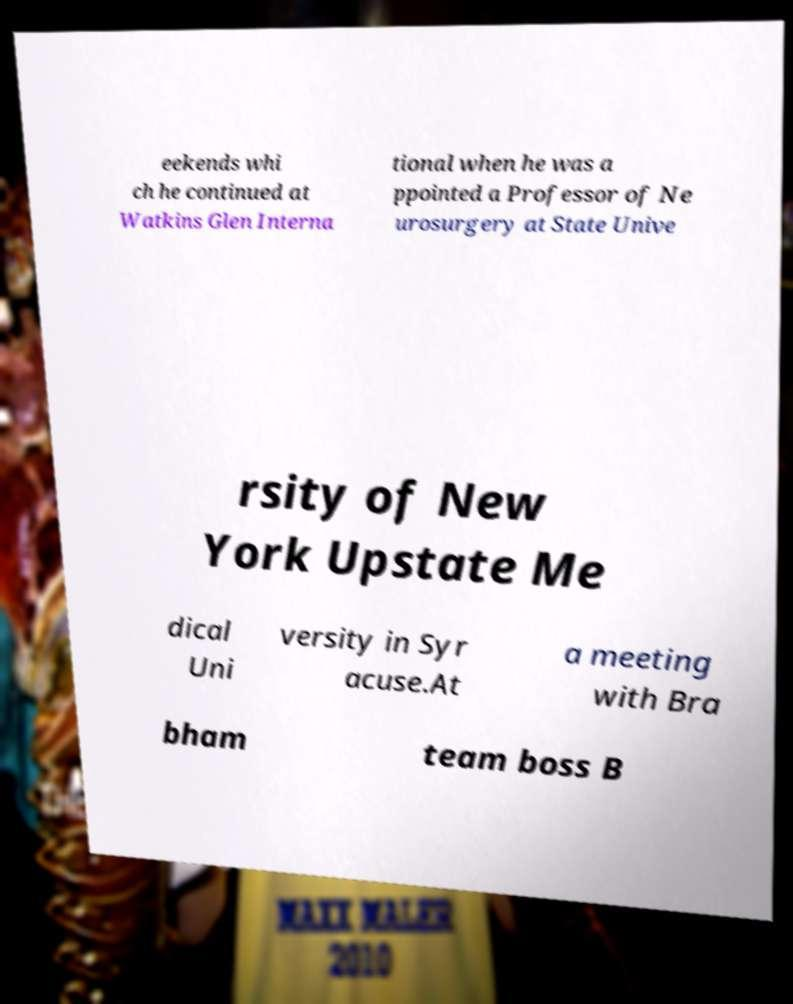Please read and relay the text visible in this image. What does it say? eekends whi ch he continued at Watkins Glen Interna tional when he was a ppointed a Professor of Ne urosurgery at State Unive rsity of New York Upstate Me dical Uni versity in Syr acuse.At a meeting with Bra bham team boss B 